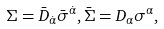Convert formula to latex. <formula><loc_0><loc_0><loc_500><loc_500>\Sigma = \bar { D } _ { \dot { \alpha } } \bar { \sigma } ^ { \dot { \alpha } } , \bar { \Sigma } = D _ { \alpha } \sigma ^ { \alpha } ,</formula> 